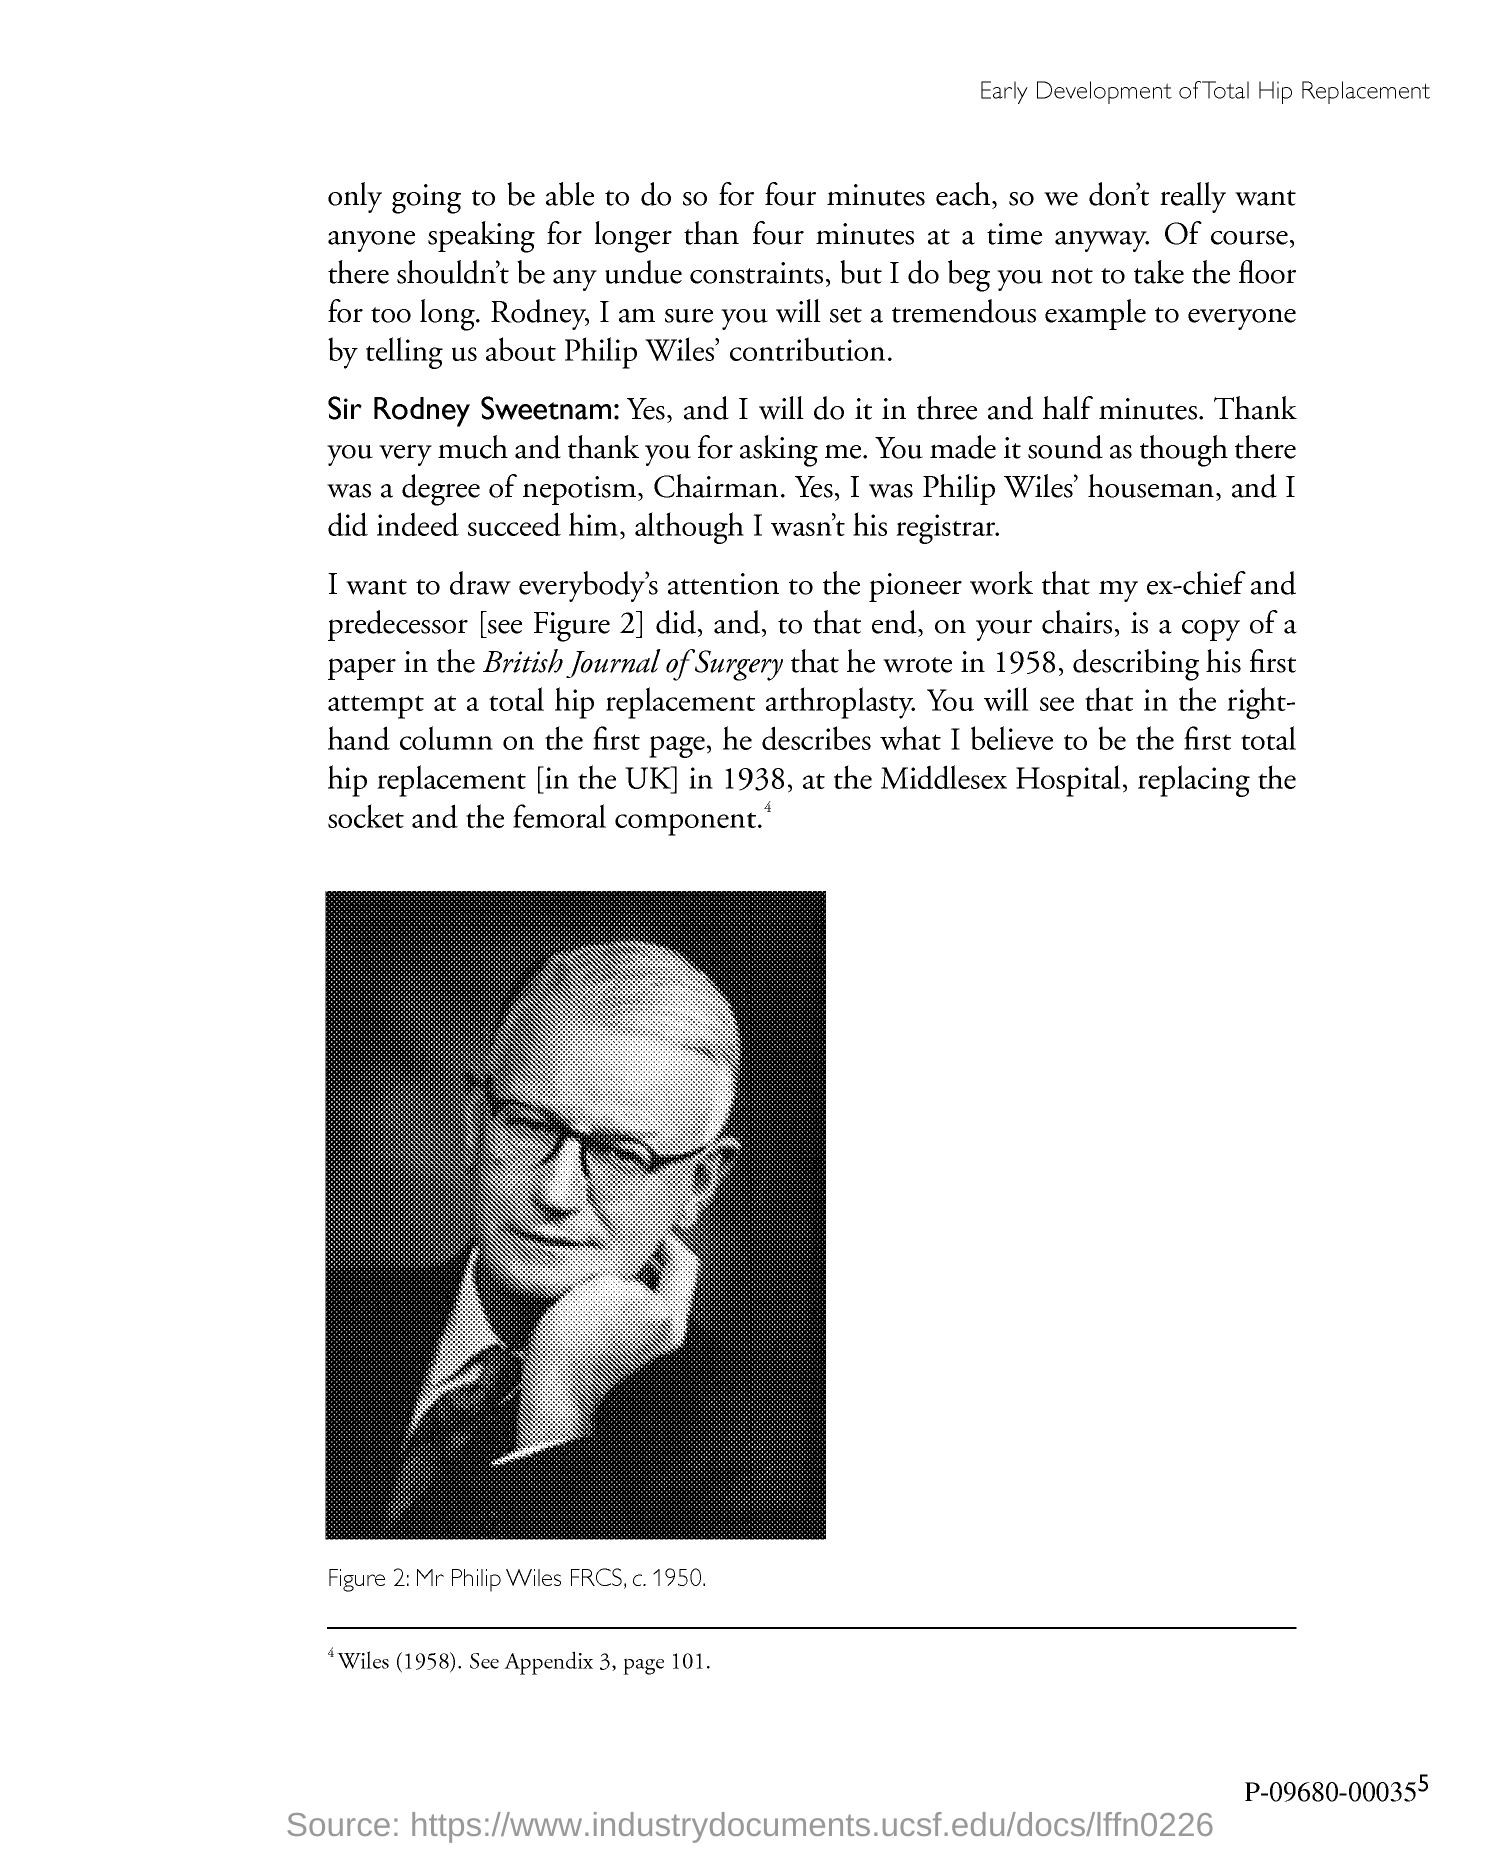When was his first hip replacement surgery done?
Ensure brevity in your answer.  1938. 